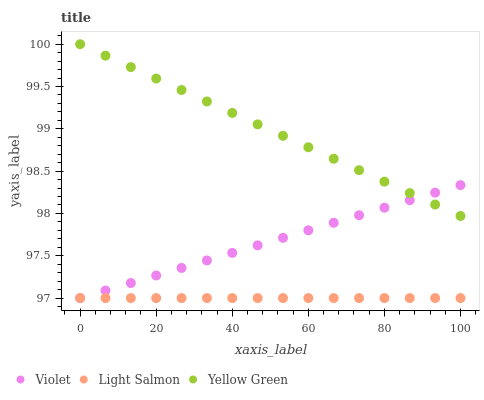Does Light Salmon have the minimum area under the curve?
Answer yes or no. Yes. Does Yellow Green have the maximum area under the curve?
Answer yes or no. Yes. Does Violet have the minimum area under the curve?
Answer yes or no. No. Does Violet have the maximum area under the curve?
Answer yes or no. No. Is Light Salmon the smoothest?
Answer yes or no. Yes. Is Violet the roughest?
Answer yes or no. Yes. Is Yellow Green the smoothest?
Answer yes or no. No. Is Yellow Green the roughest?
Answer yes or no. No. Does Light Salmon have the lowest value?
Answer yes or no. Yes. Does Yellow Green have the lowest value?
Answer yes or no. No. Does Yellow Green have the highest value?
Answer yes or no. Yes. Does Violet have the highest value?
Answer yes or no. No. Is Light Salmon less than Yellow Green?
Answer yes or no. Yes. Is Yellow Green greater than Light Salmon?
Answer yes or no. Yes. Does Violet intersect Light Salmon?
Answer yes or no. Yes. Is Violet less than Light Salmon?
Answer yes or no. No. Is Violet greater than Light Salmon?
Answer yes or no. No. Does Light Salmon intersect Yellow Green?
Answer yes or no. No. 